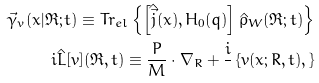Convert formula to latex. <formula><loc_0><loc_0><loc_500><loc_500>\vec { \gamma } _ { v } ( { x } | \Re ; t ) \equiv T r _ { e l } \left \{ \left [ \hat { \vec { j } } ( { x } ) , H _ { 0 } ( { q } ) \right ] \hat { \rho } _ { W } ( \Re ; t ) \right \} \\ i \hat { L } [ v ] ( \Re , t ) \equiv \frac { P } { M } \cdot \nabla _ { R } + \frac { i } { } \left \{ v ( { x ; R } , t ) , \right \}</formula> 